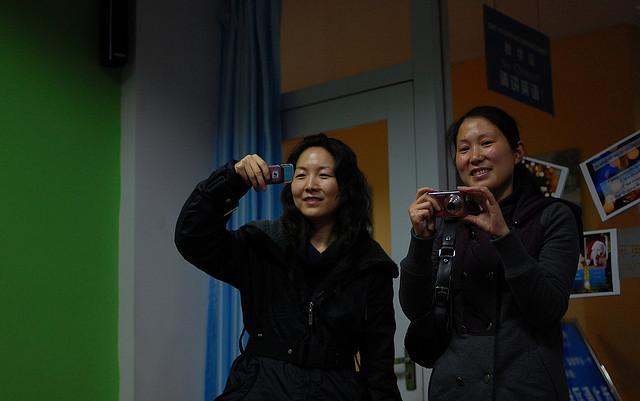What is woman wearing on her face?
Write a very short answer. Nothing. Is she playing a video game?
Keep it brief. No. Was this picture taken in the 21st century?
Write a very short answer. Yes. What is the woman taking a picture of?
Answer briefly. Herself. Is the ramp made out of snow?
Short answer required. No. Is there a clock in this photo?
Be succinct. No. Is there a chalkboard?
Write a very short answer. No. What kind of game are they playing?
Answer briefly. None. Is this woman wearing a ring?
Give a very brief answer. No. What are the people holding in their hands?
Concise answer only. Cameras. Is this person wearing stripes?
Quick response, please. No. What activity are they doing?
Write a very short answer. Taking pictures. Are all the people in this picture the same gender?
Give a very brief answer. Yes. Is this person wearing glasses?
Keep it brief. No. What is the woman holding?
Answer briefly. Camera. What color is the ladies sweater?
Answer briefly. Black. How many women have a phone in use?
Give a very brief answer. 1. What are the people doing?
Short answer required. Taking pictures. What color is the wall to the left?
Concise answer only. Green. Is the sign filled with gas?
Concise answer only. No. Who is grinning in the picture?
Keep it brief. Women. What type of art makes up the background of this portrait?
Give a very brief answer. Pictures. Do these people seem unhappy?
Answer briefly. No. What color are two of the phones?
Concise answer only. Black. Why is the woman dress that way?
Give a very brief answer. Cold. What is the woman holding in her hand?
Write a very short answer. Camera. What is in the woman's hand?
Short answer required. Camera. What race is the person?
Answer briefly. Asian. What controllers are these women holding?
Answer briefly. Camera. Has this photo been edited?
Quick response, please. No. Is the both women wearing glasses?
Write a very short answer. No. What color are the girl wearing?
Answer briefly. Black. Which photographer took the photo?
Keep it brief. Left. Is it raining?
Be succinct. No. What color is the girl's jacket?
Be succinct. Black. What type of door is behind the woman?
Give a very brief answer. Glass. What kind of jacket is she wearing?
Quick response, please. Winter. What color stands out?
Short answer required. Green. What color is the photo in?
Quick response, please. Color. When was this picture taken?
Be succinct. 2013. What motion are the people making?
Concise answer only. Taking pictures. Is the door in the background open or closed?
Short answer required. Closed. Is it daytime?
Give a very brief answer. No. What color is the curtain?
Be succinct. Blue. What is she holding?
Keep it brief. Camera. What is she taking a picture of?
Be succinct. Person. How many people are present for this photograph?
Keep it brief. 2. Is this a man or woman?
Short answer required. Woman. Are they wearing ties?
Keep it brief. No. What color is the lady's hair?
Short answer required. Black. What fashion trend is this woman subscribing to?
Quick response, please. Selfie. What are the people holding?
Give a very brief answer. Cameras. How many people in this picture are carrying bags?
Short answer required. 1. What is the person holding?
Answer briefly. Camera. What are the women doing?
Be succinct. Taking pictures. Where is this activity taking place?
Quick response, please. Picture taking. What is the door made of?
Keep it brief. Wood. What is the girl holding?
Keep it brief. Camera. What are the women holding?
Quick response, please. Cameras. What are the two objects on the wall behind the woman?
Keep it brief. Pictures. What is the color of the wall?
Answer briefly. Green. What color is the woman's sweater?
Keep it brief. Black. What is their relationship?
Short answer required. Sisters. What are the girls holding?
Write a very short answer. Cameras. Do these people look like a couple?
Give a very brief answer. No. Are they playing Wii?
Short answer required. No. Why is she holding up her phone?
Keep it brief. To take picture. Is this a baggage claim?
Write a very short answer. No. What console are these people playing with?
Quick response, please. None. What relationship might these two humans have?
Write a very short answer. Sisters. What is the girl in the background holding?
Give a very brief answer. Camera. Are the people playing Wii?
Concise answer only. No. What color are the curtains?
Answer briefly. Blue. What do these people have in their mouths?
Quick response, please. Teeth. What is the gender of the person holding the phone?
Write a very short answer. Female. What color is the women's jacket?
Short answer required. Black. What are these people holding in their hands?
Concise answer only. Phones. What color coat is on the right?
Answer briefly. Black. What is this person holding?
Keep it brief. Camera. How many people are there?
Answer briefly. 2. How many electronic devices is the person holding?
Keep it brief. 1. What is in the picture?
Write a very short answer. Women. What color is the women's hair?
Keep it brief. Black. 